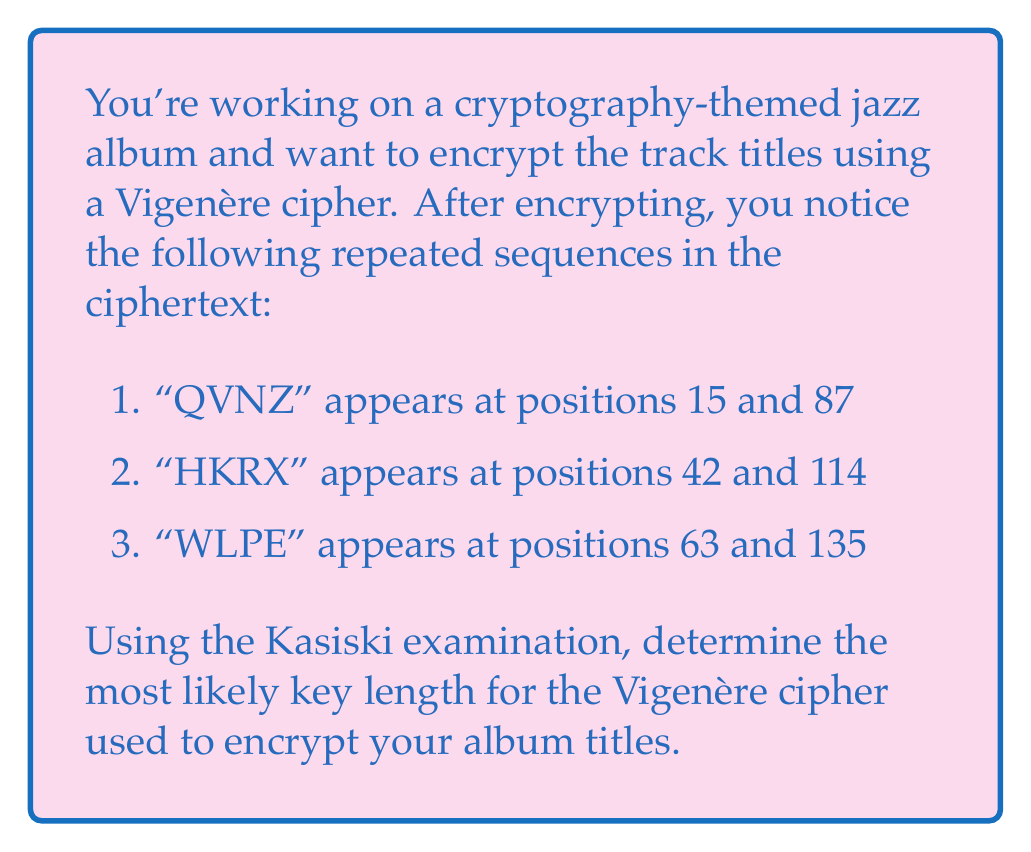Can you solve this math problem? To determine the key length using the Kasiski examination, we follow these steps:

1. Identify the distances between repeated sequences:
   - For "QVNZ": 87 - 15 = 72
   - For "HKRX": 114 - 42 = 72
   - For "WLPE": 135 - 63 = 72

2. Find the Greatest Common Divisor (GCD) of these distances:
   $$GCD(72, 72, 72) = 72$$

3. Factor 72 into its prime factors:
   $$72 = 2^3 \times 3^2$$

4. The possible key lengths are the factors of 72:
   $$\text{Factors of 72} = \{1, 2, 3, 4, 6, 8, 9, 12, 18, 24, 36, 72\}$$

5. The most likely key length is typically one of the larger factors, as very short keys are less secure and very long keys are impractical. In this case, reasonable candidates might be 8, 9, or 12.

6. Given that 72 is divisible by 8, 9, and 12 without remainder, any of these could be the key length. However, 9 is often considered a good balance between security and practicality for a Vigenère cipher.

Therefore, the most likely key length for the Vigenère cipher used to encrypt your album titles is 9.
Answer: 9 